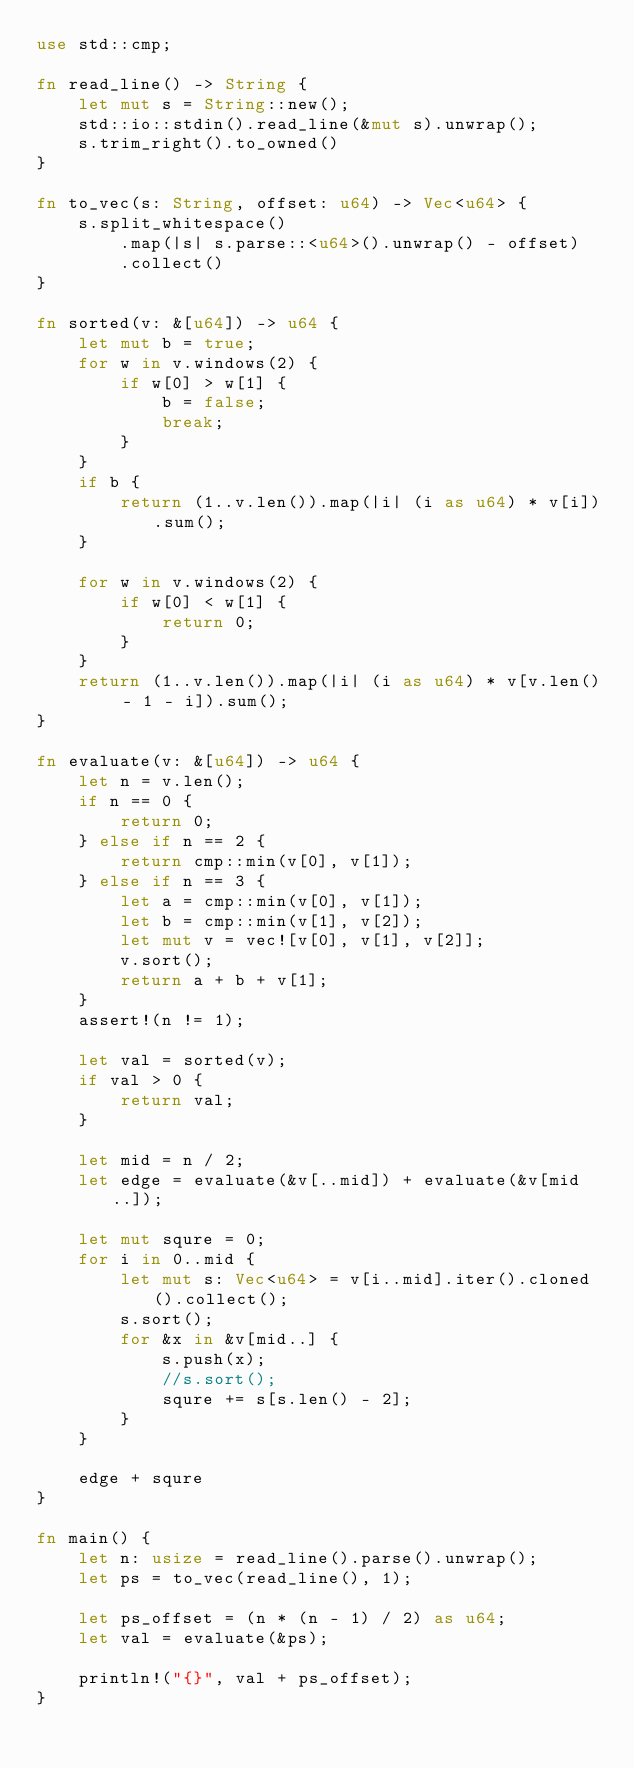<code> <loc_0><loc_0><loc_500><loc_500><_Rust_>use std::cmp;

fn read_line() -> String {
    let mut s = String::new();
    std::io::stdin().read_line(&mut s).unwrap();
    s.trim_right().to_owned()
}

fn to_vec(s: String, offset: u64) -> Vec<u64> {
    s.split_whitespace()
        .map(|s| s.parse::<u64>().unwrap() - offset)
        .collect()
}

fn sorted(v: &[u64]) -> u64 {
    let mut b = true;
    for w in v.windows(2) {
        if w[0] > w[1] {
            b = false;
            break;
        }
    }
    if b {
        return (1..v.len()).map(|i| (i as u64) * v[i]).sum();
    }

    for w in v.windows(2) {
        if w[0] < w[1] {
            return 0;
        }
    }
    return (1..v.len()).map(|i| (i as u64) * v[v.len() - 1 - i]).sum();
}

fn evaluate(v: &[u64]) -> u64 {
    let n = v.len();
    if n == 0 {
        return 0;
    } else if n == 2 {
        return cmp::min(v[0], v[1]);
    } else if n == 3 {
        let a = cmp::min(v[0], v[1]);
        let b = cmp::min(v[1], v[2]);
        let mut v = vec![v[0], v[1], v[2]];
        v.sort();
        return a + b + v[1];
    }
    assert!(n != 1);

    let val = sorted(v);
    if val > 0 {
        return val;
    }

    let mid = n / 2;
    let edge = evaluate(&v[..mid]) + evaluate(&v[mid..]);

    let mut squre = 0;
    for i in 0..mid {
        let mut s: Vec<u64> = v[i..mid].iter().cloned().collect();
        s.sort();
        for &x in &v[mid..] {
            s.push(x);
            //s.sort();
            squre += s[s.len() - 2];
        }
    }

    edge + squre
}

fn main() {
    let n: usize = read_line().parse().unwrap();
    let ps = to_vec(read_line(), 1);

    let ps_offset = (n * (n - 1) / 2) as u64;
    let val = evaluate(&ps);

    println!("{}", val + ps_offset);
}
</code> 